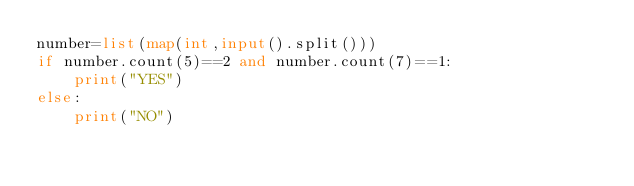<code> <loc_0><loc_0><loc_500><loc_500><_Python_>number=list(map(int,input().split()))
if number.count(5)==2 and number.count(7)==1:
    print("YES")
else:
    print("NO")</code> 